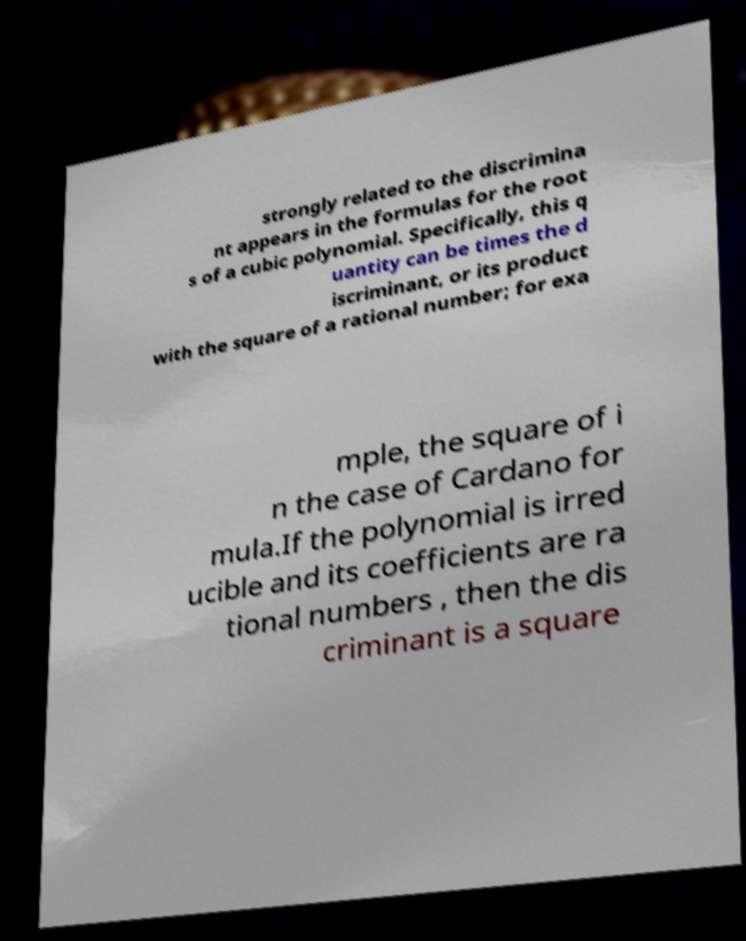Could you assist in decoding the text presented in this image and type it out clearly? strongly related to the discrimina nt appears in the formulas for the root s of a cubic polynomial. Specifically, this q uantity can be times the d iscriminant, or its product with the square of a rational number; for exa mple, the square of i n the case of Cardano for mula.If the polynomial is irred ucible and its coefficients are ra tional numbers , then the dis criminant is a square 